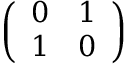Convert formula to latex. <formula><loc_0><loc_0><loc_500><loc_500>\left ( \begin{array} { c c } { 0 } & { 1 } \\ { 1 } & { 0 } \end{array} \right )</formula> 